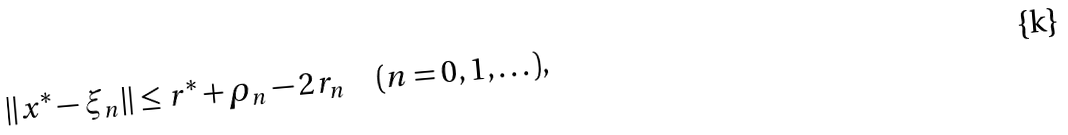<formula> <loc_0><loc_0><loc_500><loc_500>\| x ^ { * } - \xi _ { n } \| \leq r ^ { * } + \rho _ { n } - 2 r _ { n } \quad ( n = 0 , 1 , \dots ) ,</formula> 